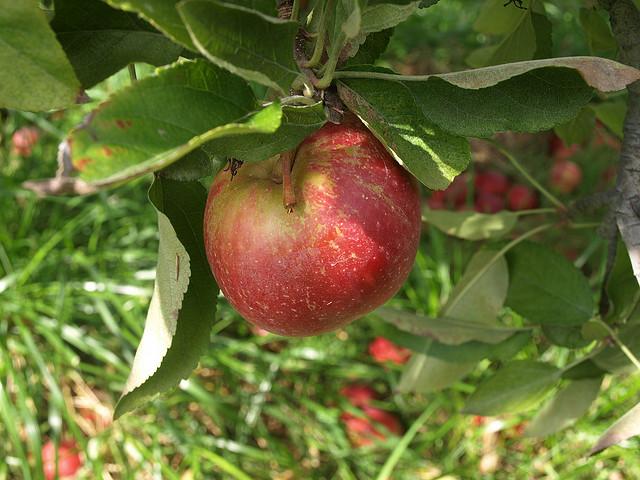Would you pick this apple?
Answer briefly. Yes. Is that a peach?
Write a very short answer. No. What is the fruit?
Concise answer only. Apple. What color are the plants?
Concise answer only. Green. How many pieces of fruit can be seen?
Give a very brief answer. 1. 